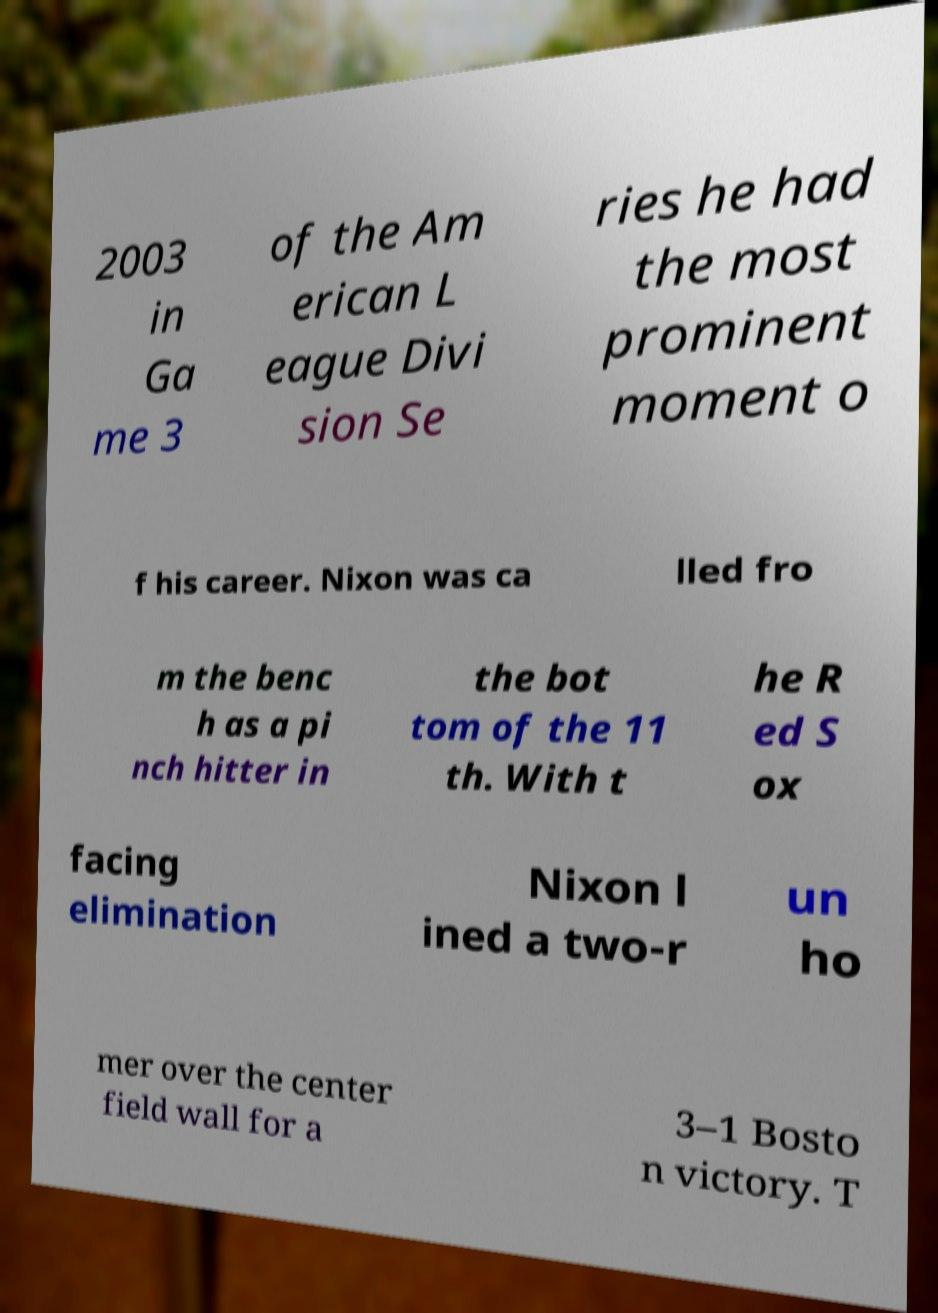Could you extract and type out the text from this image? 2003 in Ga me 3 of the Am erican L eague Divi sion Se ries he had the most prominent moment o f his career. Nixon was ca lled fro m the benc h as a pi nch hitter in the bot tom of the 11 th. With t he R ed S ox facing elimination Nixon l ined a two-r un ho mer over the center field wall for a 3–1 Bosto n victory. T 